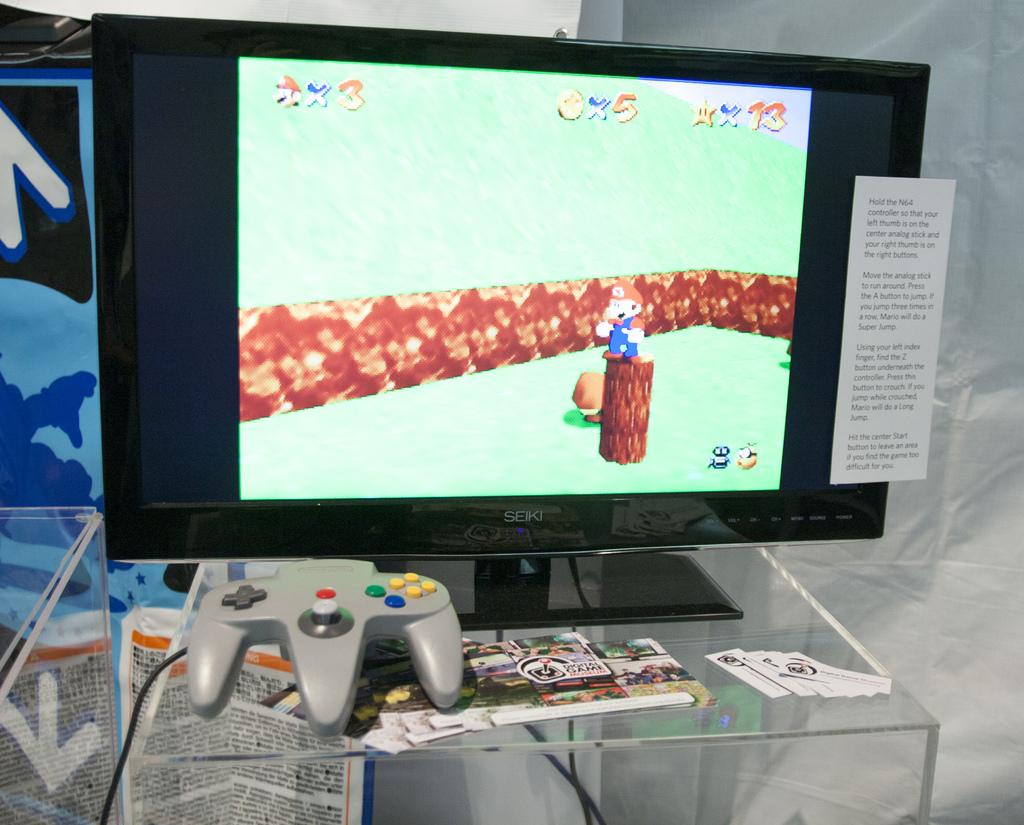What type of tv is this?
Offer a very short reply. Seiki. How many coins does mario have?
Make the answer very short. 5. 